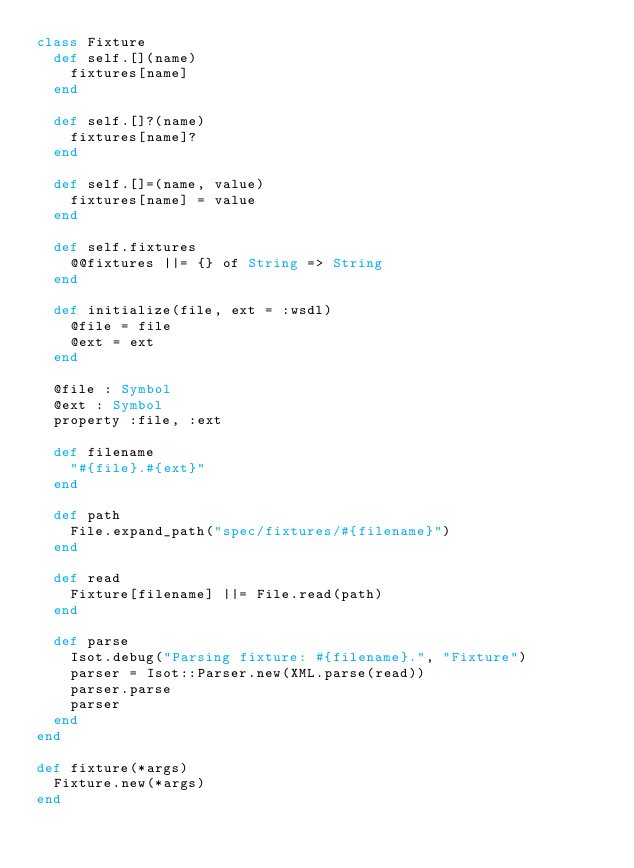Convert code to text. <code><loc_0><loc_0><loc_500><loc_500><_Crystal_>class Fixture
  def self.[](name)
    fixtures[name]
  end

  def self.[]?(name)
    fixtures[name]?
  end

  def self.[]=(name, value)
    fixtures[name] = value
  end

  def self.fixtures
    @@fixtures ||= {} of String => String
  end

  def initialize(file, ext = :wsdl)
    @file = file
    @ext = ext
  end

  @file : Symbol
  @ext : Symbol
  property :file, :ext

  def filename
    "#{file}.#{ext}"
  end

  def path
    File.expand_path("spec/fixtures/#{filename}")
  end

  def read
    Fixture[filename] ||= File.read(path)
  end

  def parse
    Isot.debug("Parsing fixture: #{filename}.", "Fixture")
    parser = Isot::Parser.new(XML.parse(read))
    parser.parse
    parser
  end
end

def fixture(*args)
  Fixture.new(*args)
end
</code> 